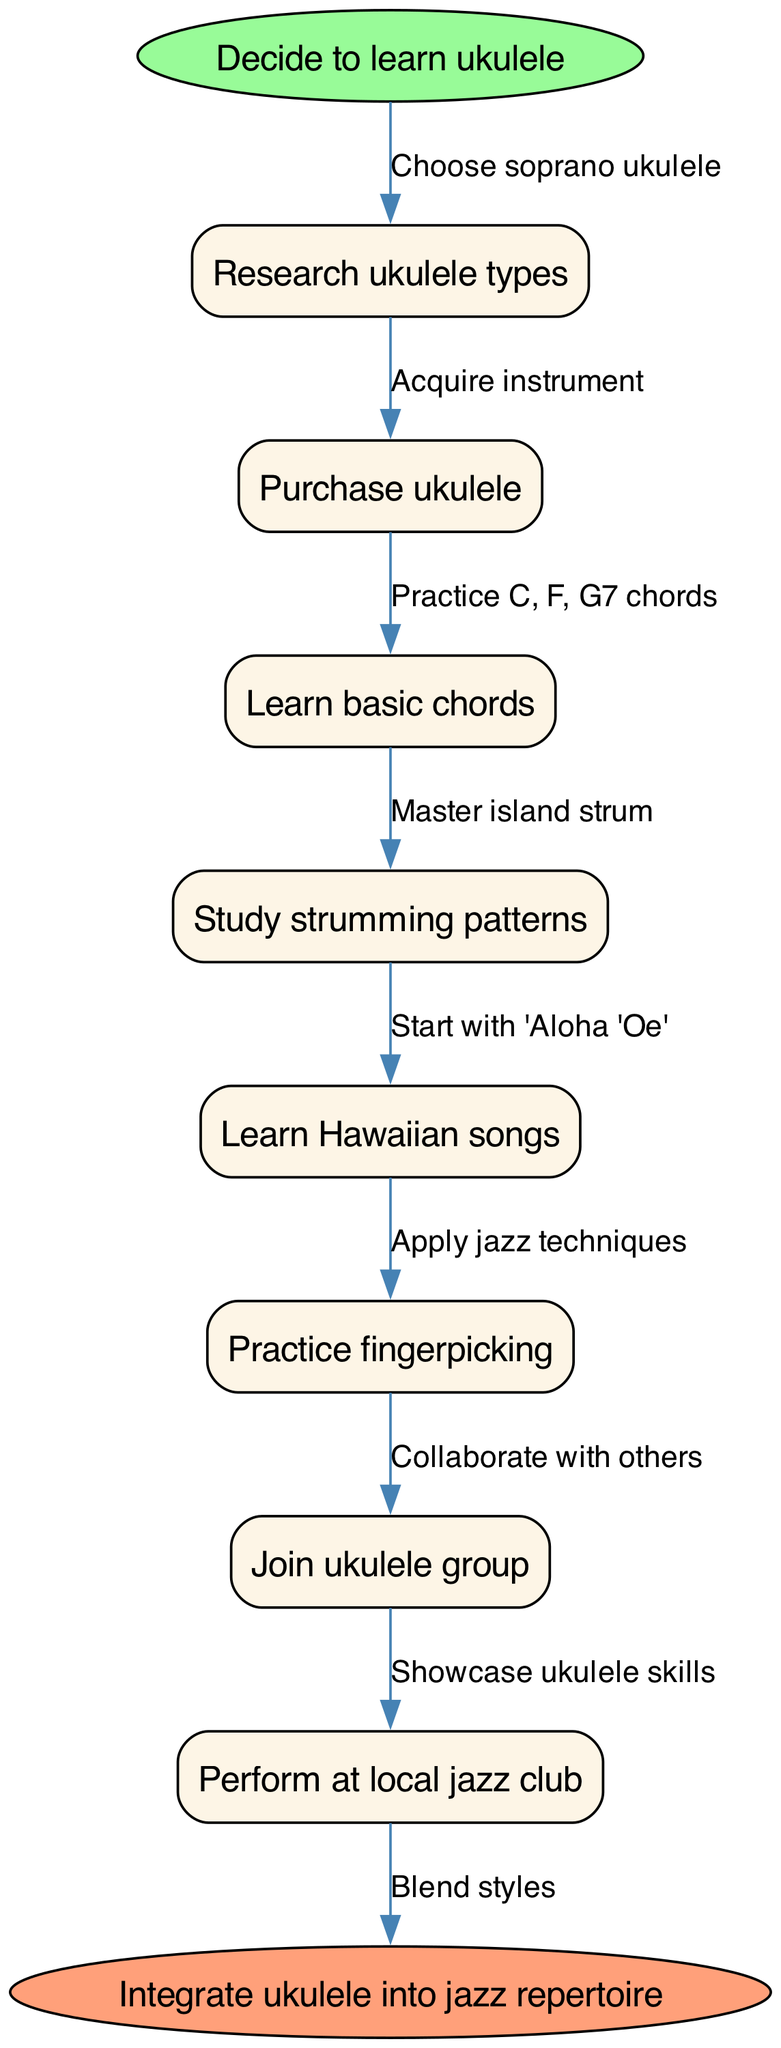What is the first step in the process? The diagram indicates the first step is to "Decide to learn ukulele," which is the starting node.
Answer: Decide to learn ukulele How many steps are outlined in the diagram? By counting the individual steps listed in the diagram, there are a total of 8 steps from "Research ukulele types" to "Perform at local jazz club."
Answer: 8 What is the last step before integrating the ukulele into the jazz repertoire? The last step in the flow before reaching the end node is "Perform at local jazz club." This is the final activity before integrating skills into the jazz repertoire.
Answer: Perform at local jazz club What is the edge connecting "Learn basic chords" to the next step? The edge indicates the specific action taken after "Learn basic chords," which is to "Practice C, F, G7 chords," clearly depicting what needs to be practiced.
Answer: Practice C, F, G7 chords What node comes after "Study strumming patterns"? After "Study strumming patterns," the next node in the flow chart is "Learn Hawaiian songs," indicating a progression in learning after mastering strumming techniques.
Answer: Learn Hawaiian songs What is the relationship between "Join ukulele group" and "Perform at local jazz club"? The relationship is direct, as the edge indicates that after joining a group, one is prompted to "Collaborate with others," which leads into the next step of performing.
Answer: Collaborate with others Which step involves applying jazz techniques? The step that specifically mentions applying jazz techniques is "Practice fingerpicking," highlighting the integration of jazz into the learning process.
Answer: Practice fingerpicking What are the two types of ukulele mentioned in the research step? The diagram specifies that during the "Research ukulele types," one "Choose soprano ukulele," indicating a specific choice among other types without explicitly naming others but showcasing a definitive action.
Answer: Choose soprano ukulele What final action is represented at the end of the process? The final action represented is "Integrate ukulele into jazz repertoire," suggesting the culmination of various skills learned throughout the steps to blend styles.
Answer: Integrate ukulele into jazz repertoire 